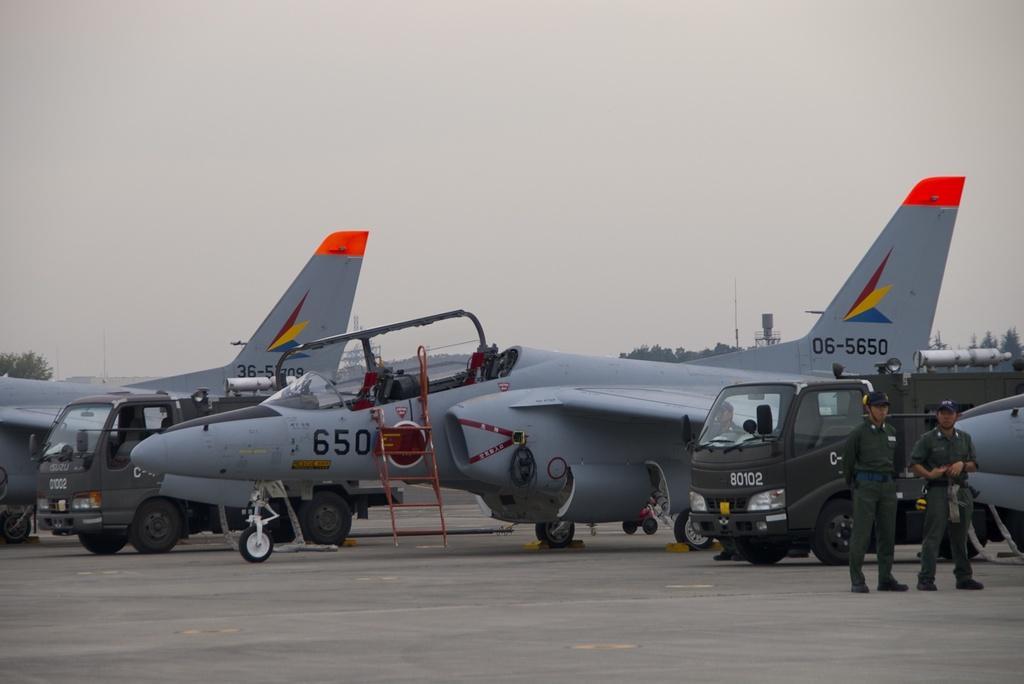Describe this image in one or two sentences. In this image there are vehicles and aeroplanes on the road. Beside them there are two persons standing. At the back side there are trees, water tank and at the top there is sky. 